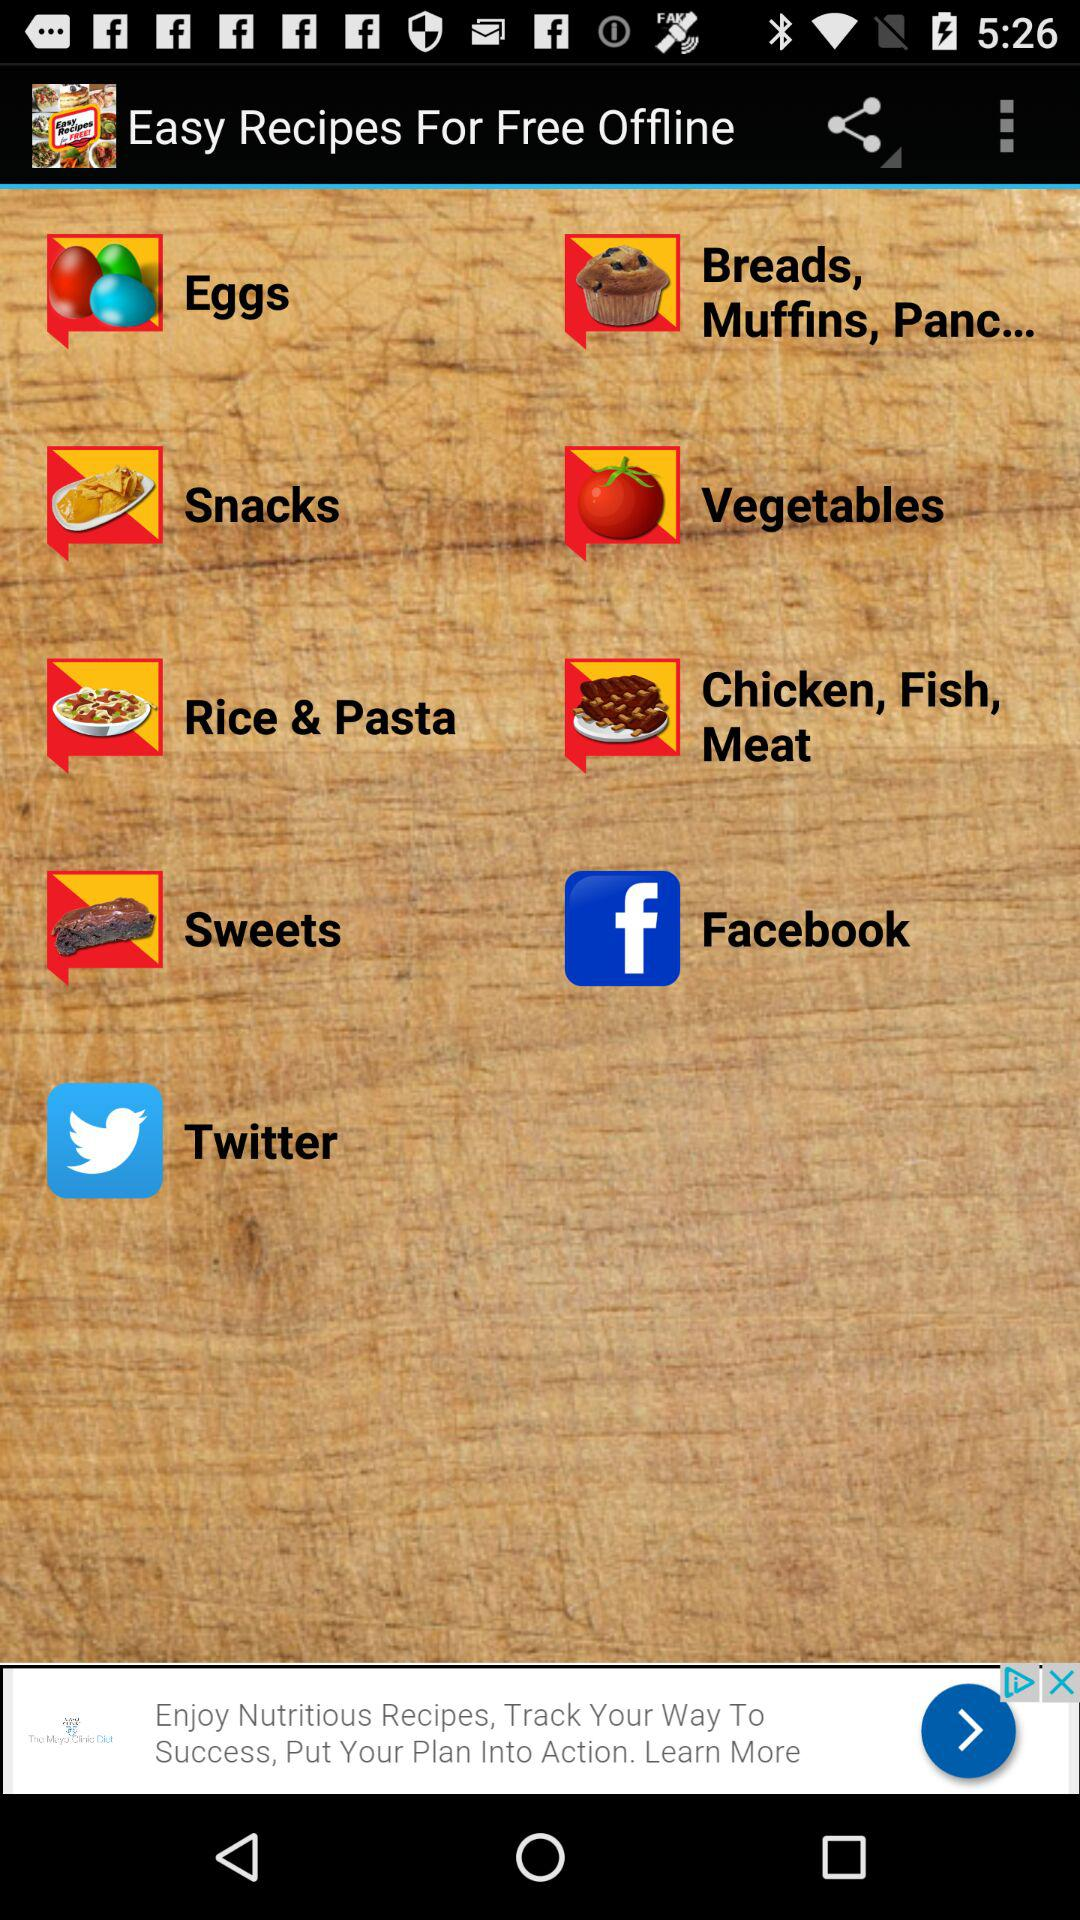How long does the sweets recipe take to prepare?
When the provided information is insufficient, respond with <no answer>. <no answer> 